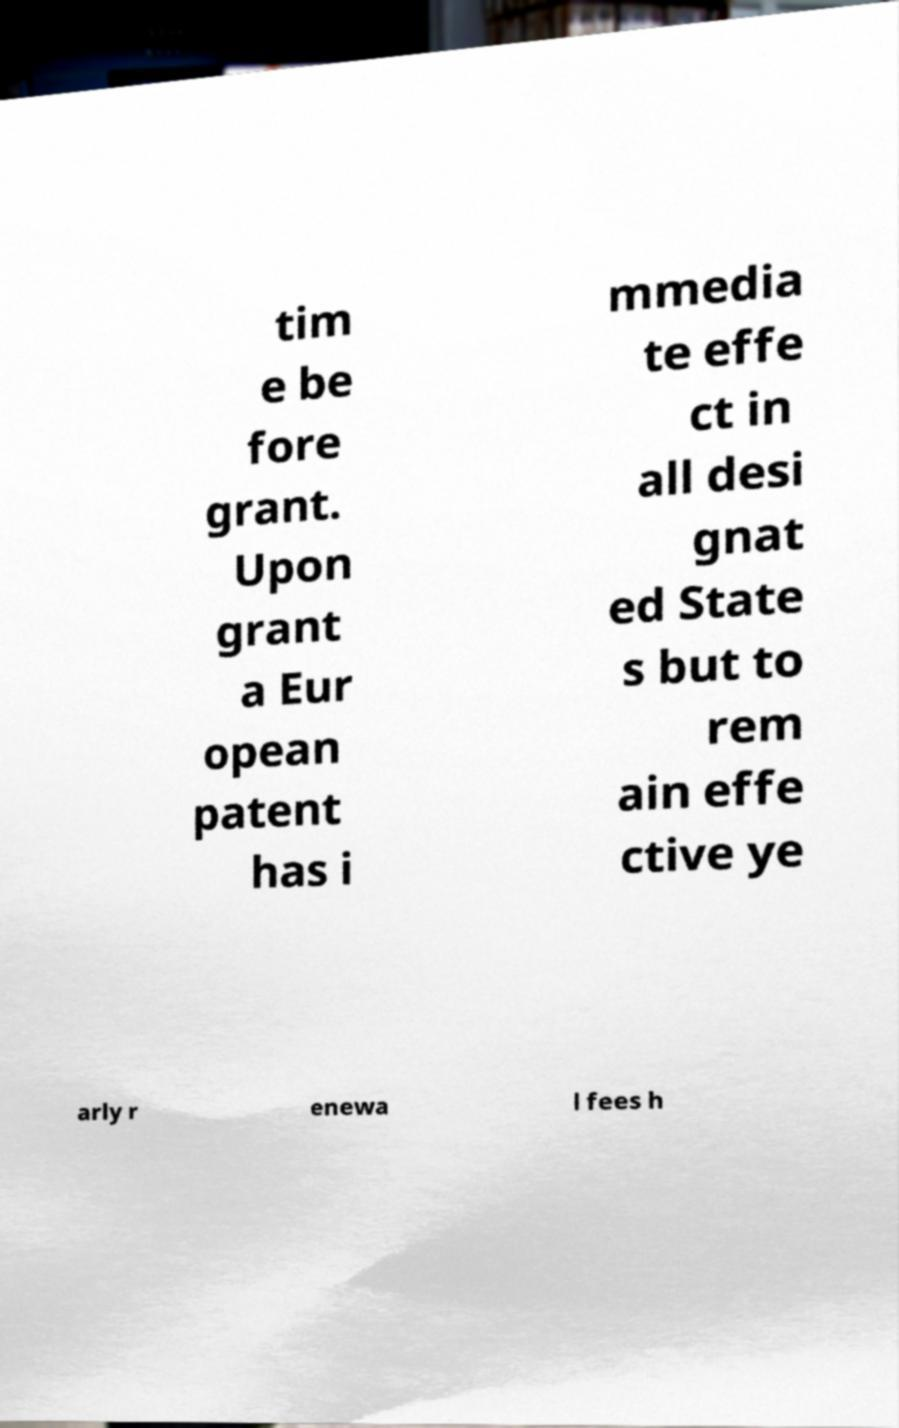What messages or text are displayed in this image? I need them in a readable, typed format. tim e be fore grant. Upon grant a Eur opean patent has i mmedia te effe ct in all desi gnat ed State s but to rem ain effe ctive ye arly r enewa l fees h 